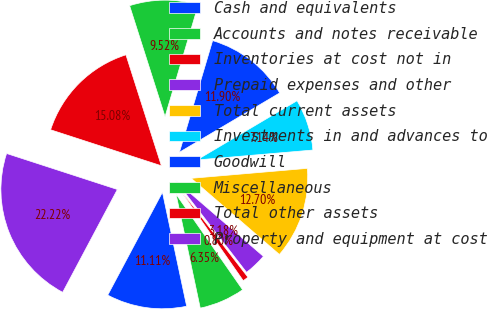Convert chart to OTSL. <chart><loc_0><loc_0><loc_500><loc_500><pie_chart><fcel>Cash and equivalents<fcel>Accounts and notes receivable<fcel>Inventories at cost not in<fcel>Prepaid expenses and other<fcel>Total current assets<fcel>Investments in and advances to<fcel>Goodwill<fcel>Miscellaneous<fcel>Total other assets<fcel>Property and equipment at cost<nl><fcel>11.11%<fcel>6.35%<fcel>0.8%<fcel>3.18%<fcel>12.7%<fcel>7.14%<fcel>11.9%<fcel>9.52%<fcel>15.08%<fcel>22.22%<nl></chart> 